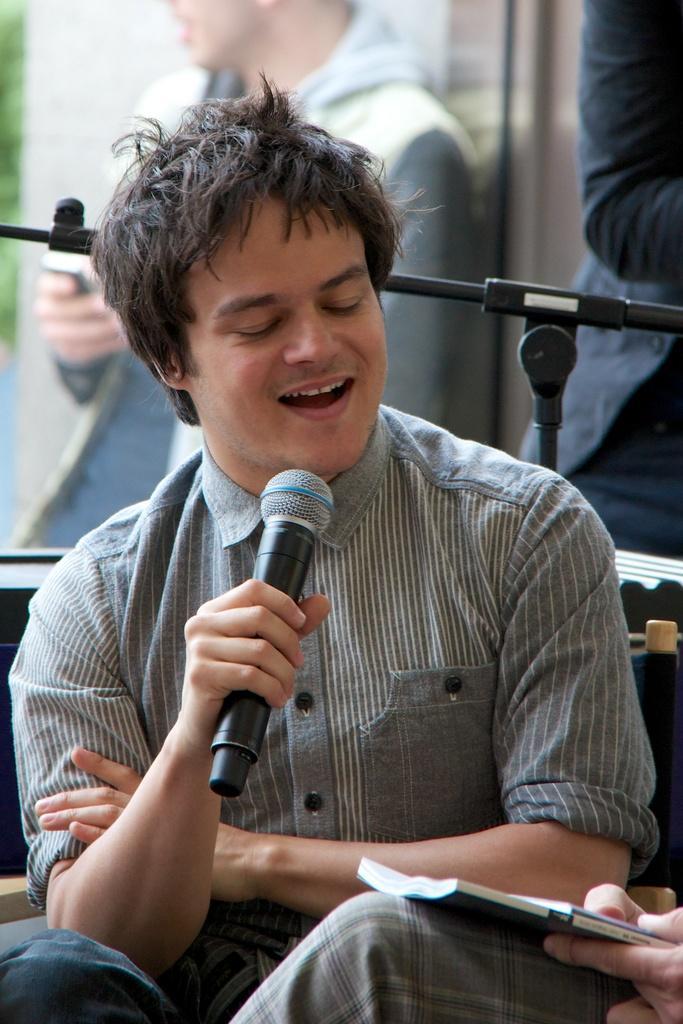Can you describe this image briefly? A man i sitting holding a mic. He is singing closing his eye. He wears a shirt with stripes on it. There is a mic stand behind him and few people. 